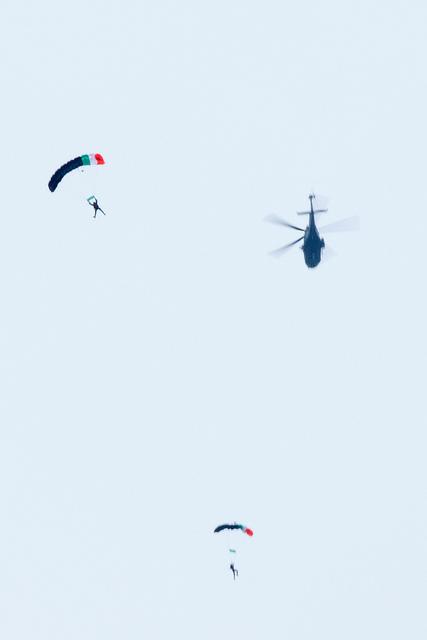What kind of aircraft can be seen?
Answer briefly. Helicopter. Is it nighttime? Is it nighttime?
Keep it brief. No. Why are the people in this picture using parachutes?
Give a very brief answer. Skydiving. 